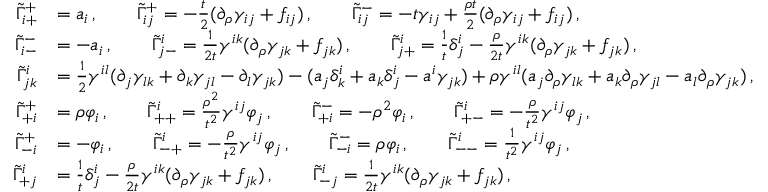Convert formula to latex. <formula><loc_0><loc_0><loc_500><loc_500>\begin{array} { r l } { \tilde { \Gamma } ^ { + } _ { i + } } & { = a _ { i } \, , \quad \tilde { \Gamma } ^ { + } _ { i j } = - \frac { t } { 2 } ( \partial _ { \rho } \gamma _ { i j } + f _ { i j } ) \, , \quad \tilde { \Gamma } ^ { - } _ { i j } = - t \gamma _ { i j } + \frac { \rho t } { 2 } ( \partial _ { \rho } \gamma _ { i j } + f _ { i j } ) \, , } \\ { \tilde { \Gamma } ^ { - } _ { i - } } & { = - a _ { i } \, , \quad \tilde { \Gamma } ^ { i } _ { j - } = \frac { 1 } { 2 t } \gamma ^ { i k } ( \partial _ { \rho } \gamma _ { j k } + f _ { j k } ) \, , \quad \tilde { \Gamma } ^ { i } _ { j + } = \frac { 1 } { t } \delta ^ { i } _ { j } - \frac { \rho } { 2 t } \gamma ^ { i k } ( \partial _ { \rho } \gamma _ { j k } + f _ { j k } ) \, , } \\ { \tilde { \Gamma } ^ { i } _ { j k } } & { = \frac { 1 } { 2 } \gamma ^ { i l } ( \partial _ { j } \gamma _ { l k } + \partial _ { k } \gamma _ { j l } - \partial _ { l } \gamma _ { j k } ) - ( a _ { j } \delta ^ { i } _ { k } + a _ { k } \delta ^ { i } _ { j } - a ^ { i } \gamma _ { j k } ) + \rho \gamma ^ { i l } ( a _ { j } \partial _ { \rho } \gamma _ { l k } + a _ { k } \partial _ { \rho } \gamma _ { j l } - a _ { l } \partial _ { \rho } \gamma _ { j k } ) \, , } \\ { \tilde { \Gamma } ^ { + } _ { + i } } & { = \rho \varphi _ { i } \, , \quad \tilde { \Gamma } ^ { i } _ { + + } = \frac { \rho ^ { 2 } } { t ^ { 2 } } \gamma ^ { i j } \varphi _ { j } \, , \quad \tilde { \Gamma } ^ { - } _ { + i } = - \rho ^ { 2 } \varphi _ { i } \, , \quad \tilde { \Gamma } ^ { i } _ { + - } = - \frac { \rho } { t ^ { 2 } } \gamma ^ { i j } \varphi _ { j } \, , } \\ { \tilde { \Gamma } ^ { + } _ { - i } } & { = - \varphi _ { i } \, , \quad \tilde { \Gamma } ^ { i } _ { - + } = - \frac { \rho } { t ^ { 2 } } \gamma ^ { i j } \varphi _ { j } \, , \quad \tilde { \Gamma } ^ { - } _ { - i } = \rho \varphi _ { i } \, , \quad \tilde { \Gamma } ^ { i } _ { - - } = \frac { 1 } { t ^ { 2 } } \gamma ^ { i j } \varphi _ { j } \, , } \\ { \tilde { \Gamma } ^ { i } _ { + j } } & { = \frac { 1 } { t } \delta ^ { i } _ { j } - \frac { \rho } { 2 t } \gamma ^ { i k } ( \partial _ { \rho } \gamma _ { j k } + f _ { j k } ) \, , \quad \tilde { \Gamma } ^ { i } _ { - j } = \frac { 1 } { 2 t } \gamma ^ { i k } ( \partial _ { \rho } \gamma _ { j k } + f _ { j k } ) \, , } \end{array}</formula> 